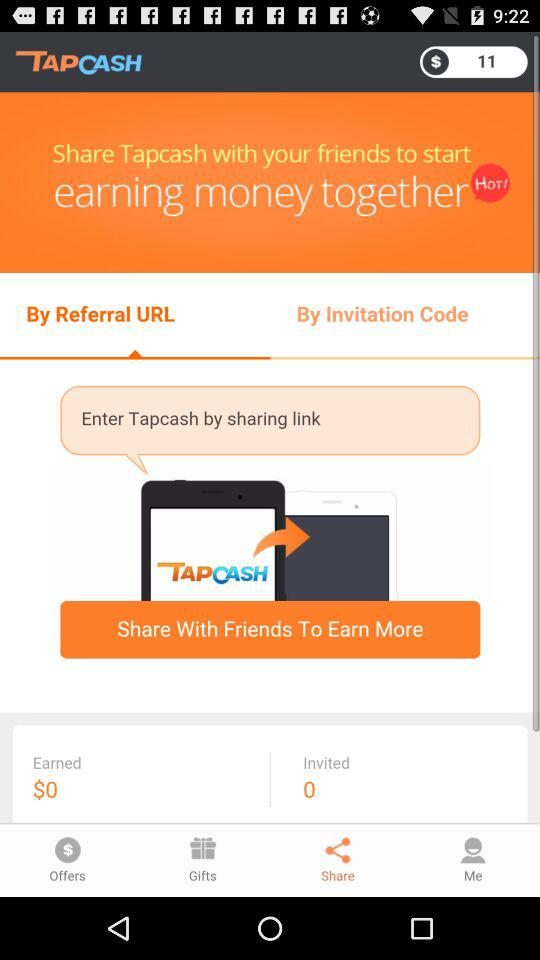Which tab is selected? The selected tabs are "By Referral URL" and "Share". 